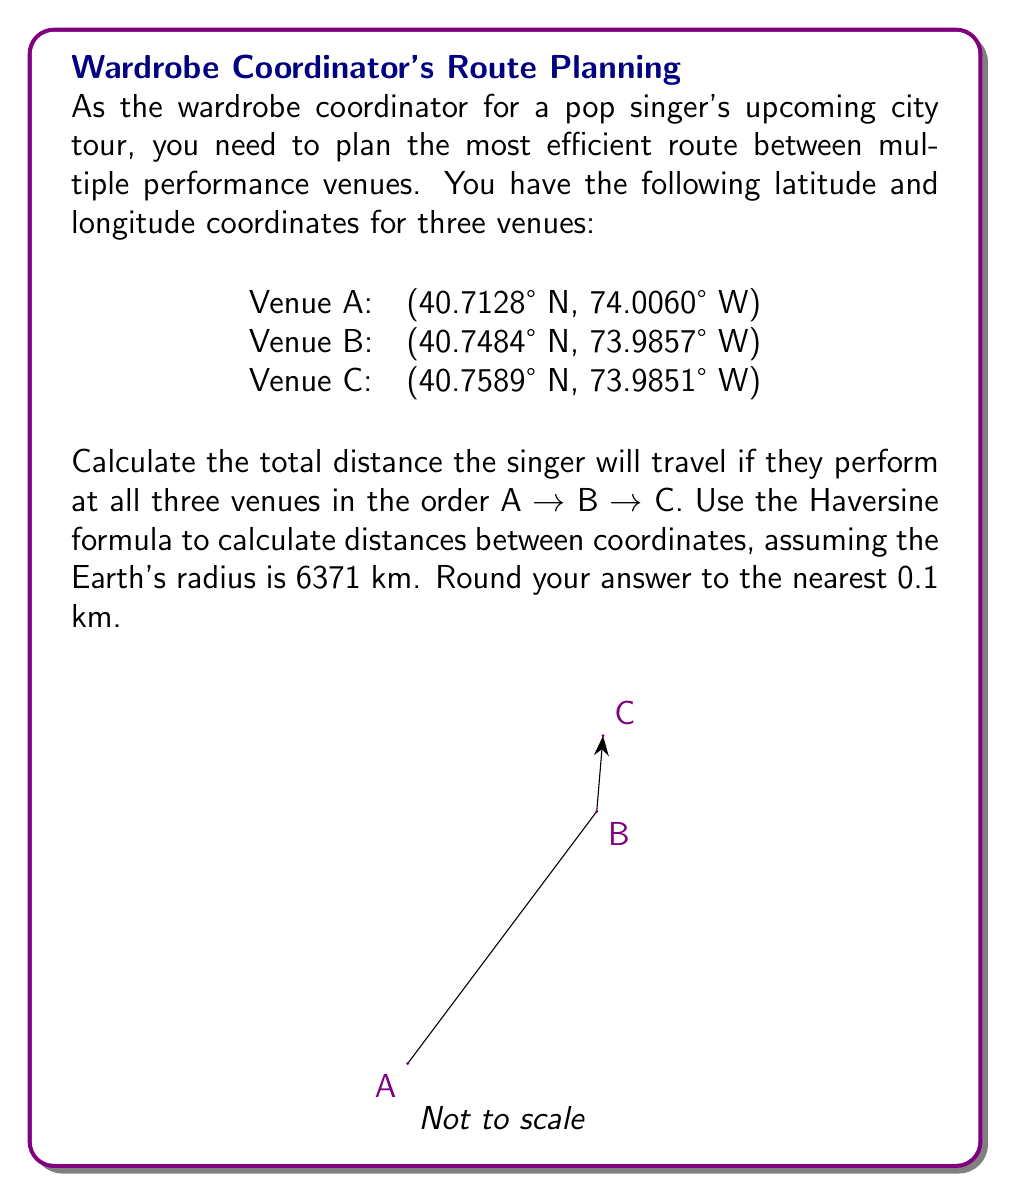Show me your answer to this math problem. To solve this problem, we'll use the Haversine formula to calculate the distance between each pair of coordinates. The Haversine formula is:

$$d = 2r \arcsin\left(\sqrt{\sin^2\left(\frac{\phi_2 - \phi_1}{2}\right) + \cos(\phi_1)\cos(\phi_2)\sin^2\left(\frac{\lambda_2 - \lambda_1}{2}\right)}\right)$$

Where:
$d$ is the distance between two points on a sphere
$r$ is the radius of the sphere (in this case, Earth's radius = 6371 km)
$\phi_1, \phi_2$ are the latitudes of point 1 and point 2 in radians
$\lambda_1, \lambda_2$ are the longitudes of point 1 and point 2 in radians

Step 1: Convert all coordinates from degrees to radians
$$\text{radians} = \text{degrees} \times \frac{\pi}{180}$$

Venue A: (0.7104 rad, -1.2917 rad)
Venue B: (0.7108 rad, -1.2909 rad)
Venue C: (0.7110 rad, -1.2908 rad)

Step 2: Calculate distance from A to B
Using the Haversine formula:
$$d_{AB} = 2 \times 6371 \times \arcsin\left(\sqrt{\sin^2\left(\frac{0.7108 - 0.7104}{2}\right) + \cos(0.7104)\cos(0.7108)\sin^2\left(\frac{-1.2909 - (-1.2917)}{2}\right)}\right)$$
$$d_{AB} = 4.0 \text{ km}$$

Step 3: Calculate distance from B to C
$$d_{BC} = 2 \times 6371 \times \arcsin\left(\sqrt{\sin^2\left(\frac{0.7110 - 0.7108}{2}\right) + \cos(0.7108)\cos(0.7110)\sin^2\left(\frac{-1.2908 - (-1.2909)}{2}\right)}\right)$$
$$d_{BC} = 1.2 \text{ km}$$

Step 4: Sum the distances
Total distance = $d_{AB} + d_{BC} = 4.0 + 1.2 = 5.2 \text{ km}$
Answer: 5.2 km 